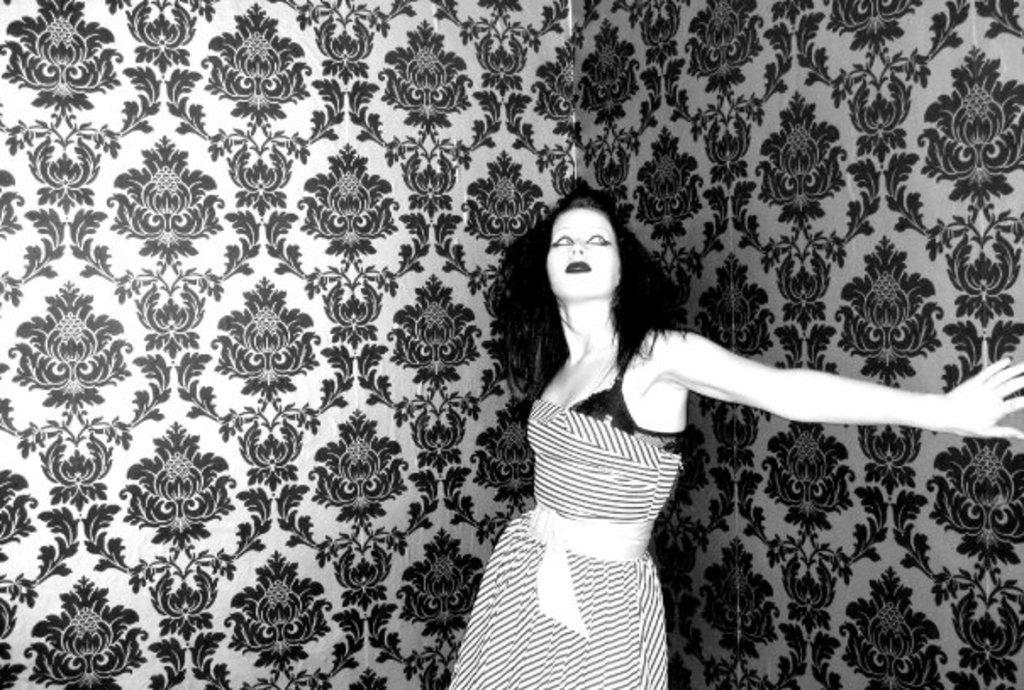What is the main subject in the image? There is a person standing in the image. Can you describe the background of the image? There are designs on the walls in the image. What type of toy can be seen on the earth in the image? There is no toy or reference to the earth present in the image. 